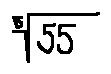Convert formula to latex. <formula><loc_0><loc_0><loc_500><loc_500>\sqrt { [ } 5 ] { 5 5 }</formula> 